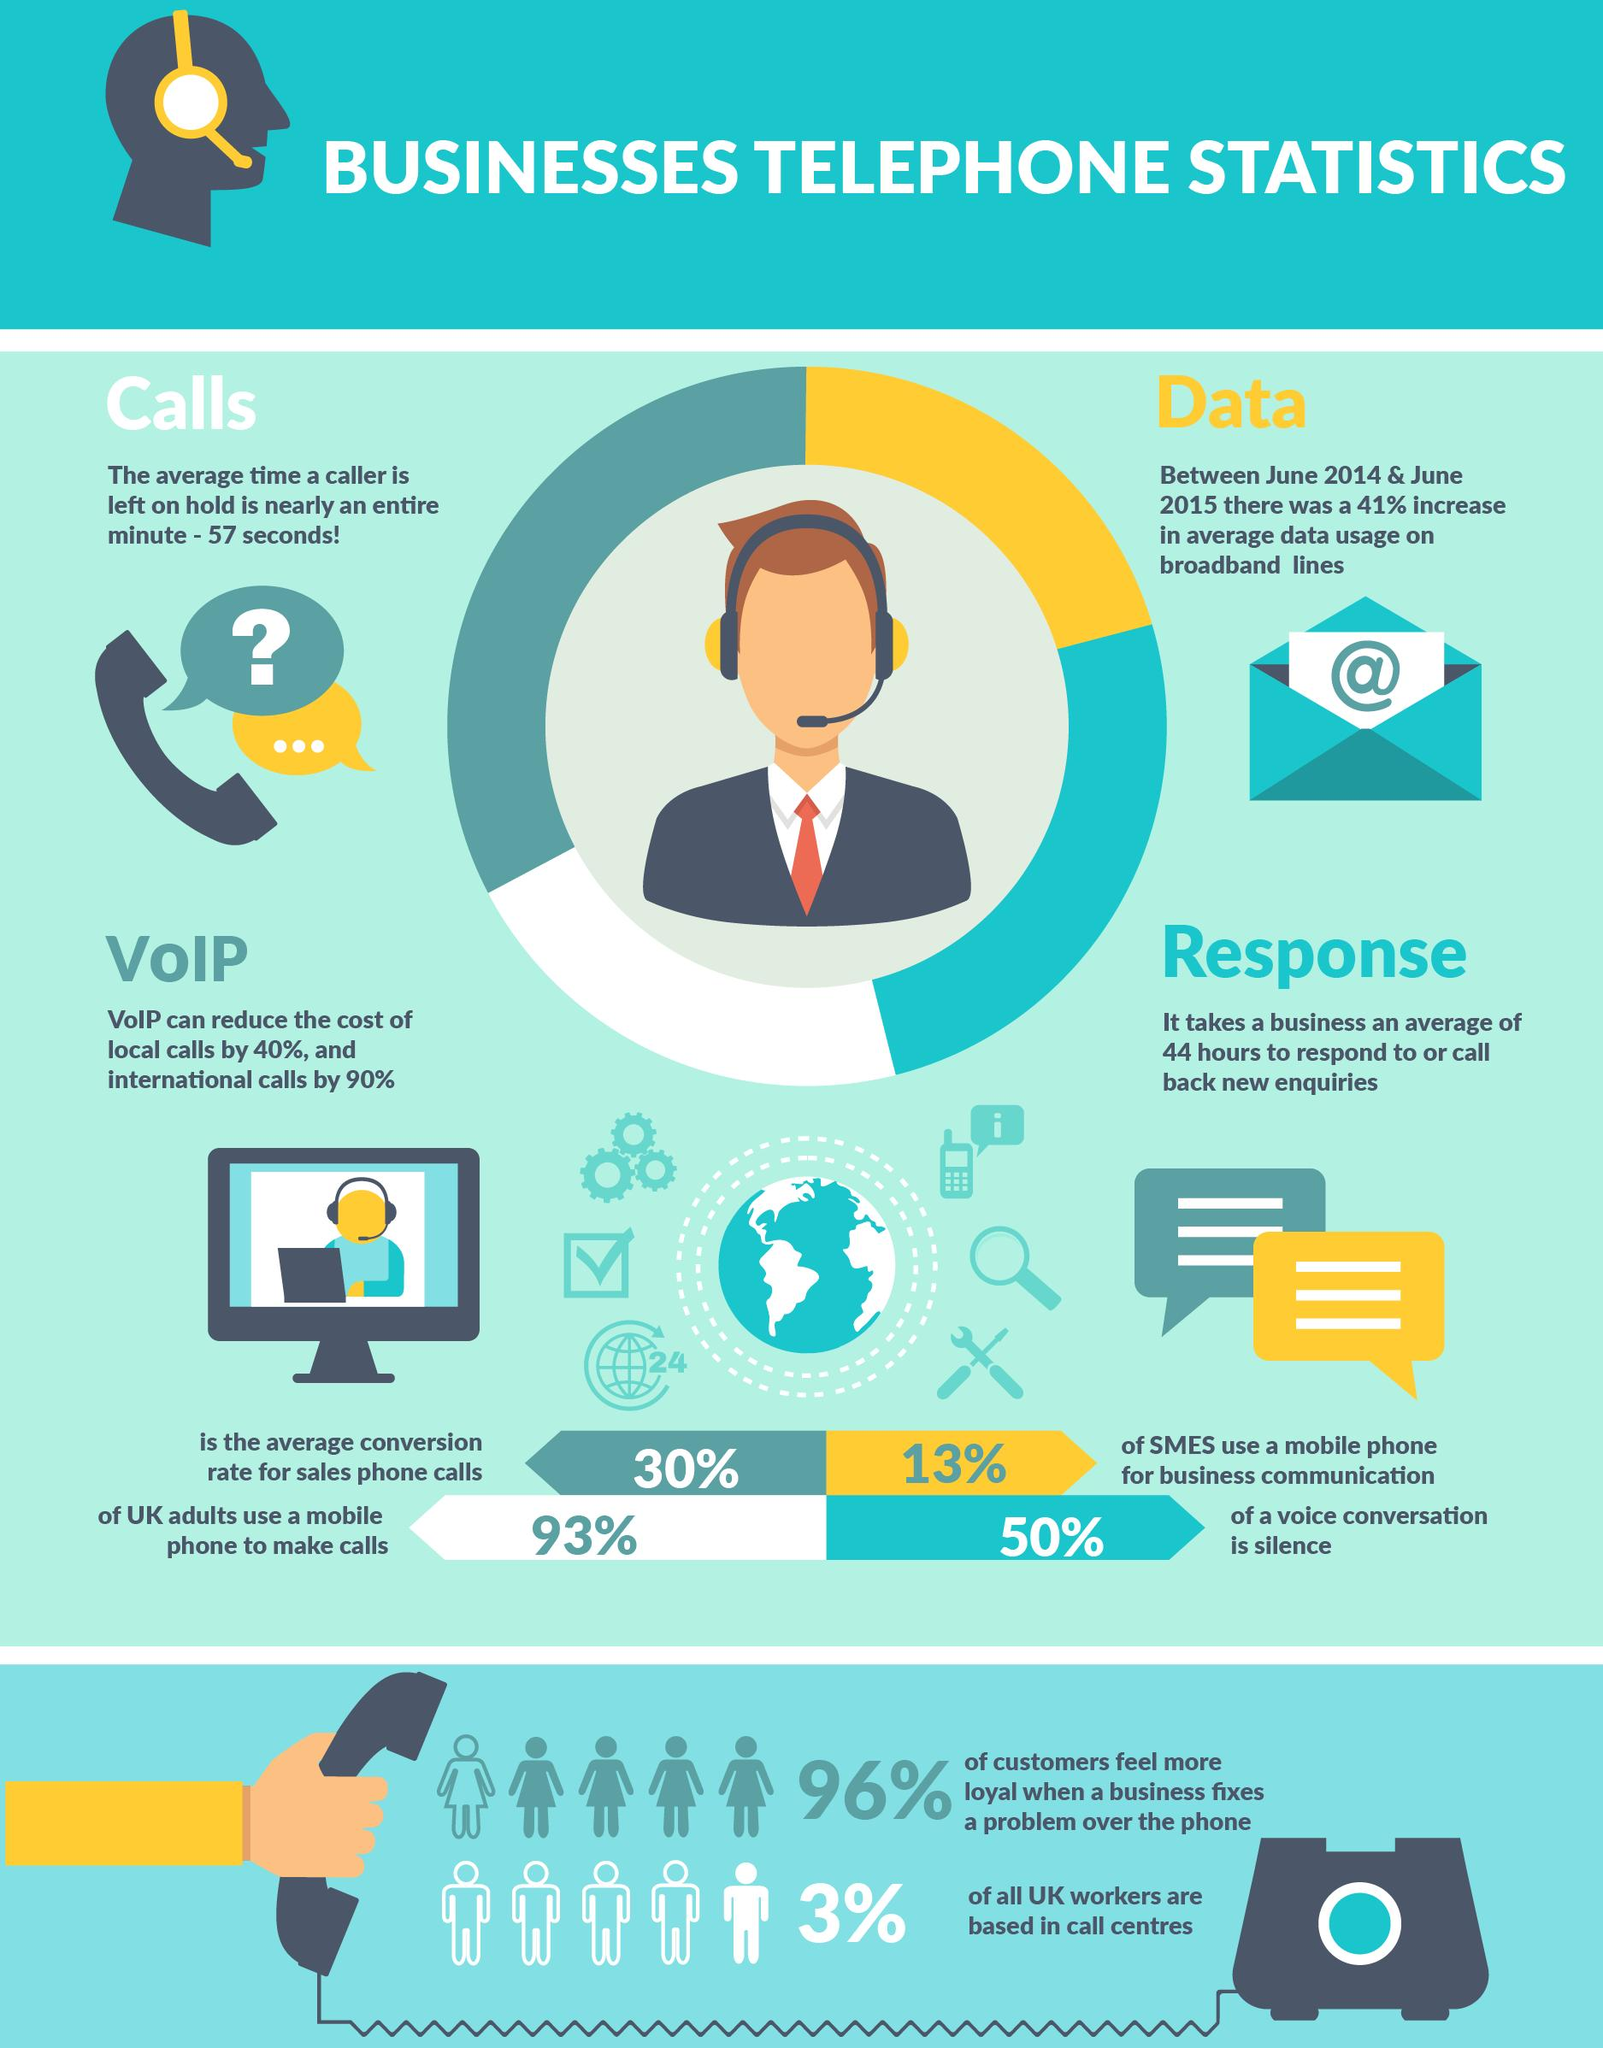Indicate a few pertinent items in this graphic. A recent survey in the UK found that only 4% of customers do not feel loyal to a business when the issue is resolved over the phone. According to a recent survey, it was found that 97% of all UK workers are not based in call centers. According to a recent study, 87% of small and medium-sized enterprises (SMEs) in the UK do not use a mobile phone for business communication. 